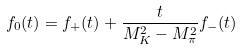Convert formula to latex. <formula><loc_0><loc_0><loc_500><loc_500>f _ { 0 } ( t ) = f _ { + } ( t ) + \frac { t } { M _ { K } ^ { 2 } - M _ { \pi } ^ { 2 } } f _ { - } ( t )</formula> 